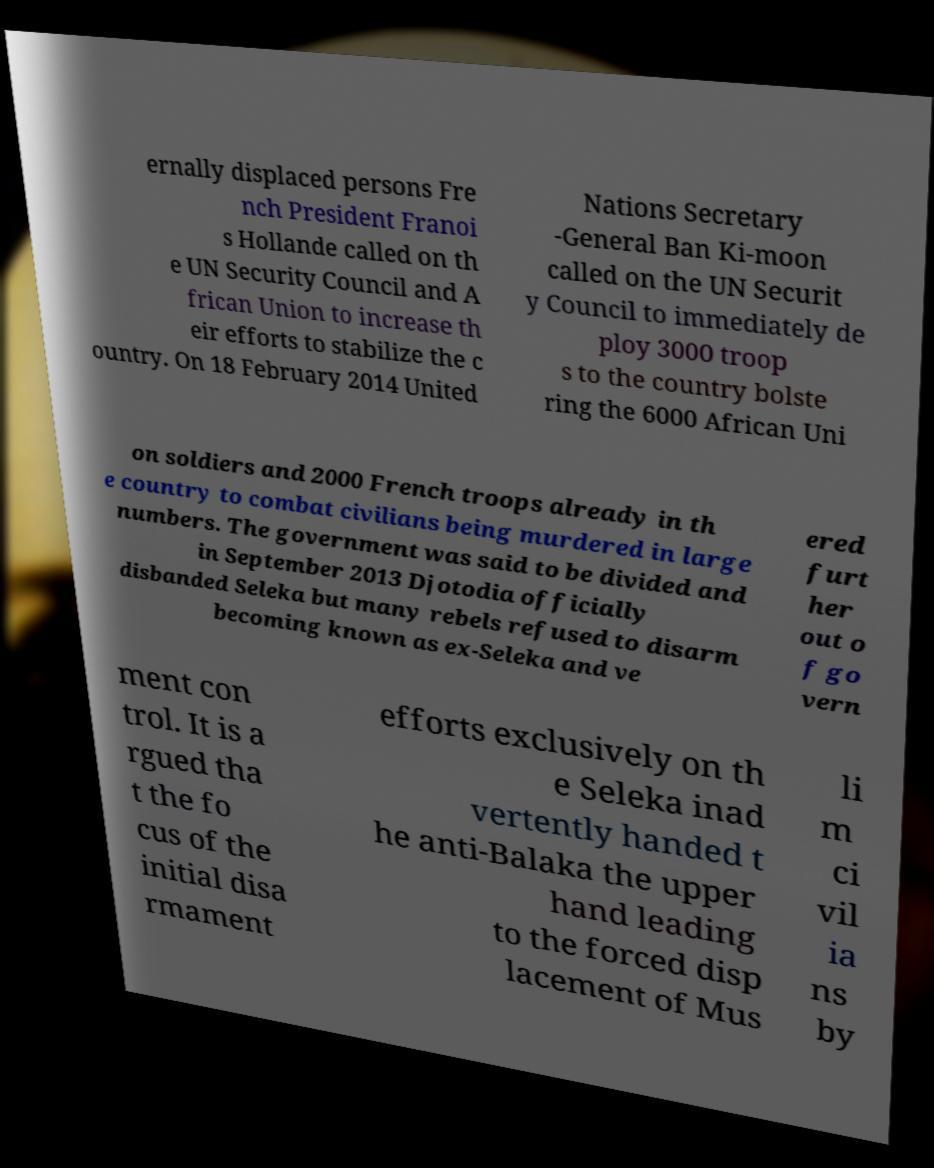For documentation purposes, I need the text within this image transcribed. Could you provide that? ernally displaced persons Fre nch President Franoi s Hollande called on th e UN Security Council and A frican Union to increase th eir efforts to stabilize the c ountry. On 18 February 2014 United Nations Secretary -General Ban Ki-moon called on the UN Securit y Council to immediately de ploy 3000 troop s to the country bolste ring the 6000 African Uni on soldiers and 2000 French troops already in th e country to combat civilians being murdered in large numbers. The government was said to be divided and in September 2013 Djotodia officially disbanded Seleka but many rebels refused to disarm becoming known as ex-Seleka and ve ered furt her out o f go vern ment con trol. It is a rgued tha t the fo cus of the initial disa rmament efforts exclusively on th e Seleka inad vertently handed t he anti-Balaka the upper hand leading to the forced disp lacement of Mus li m ci vil ia ns by 